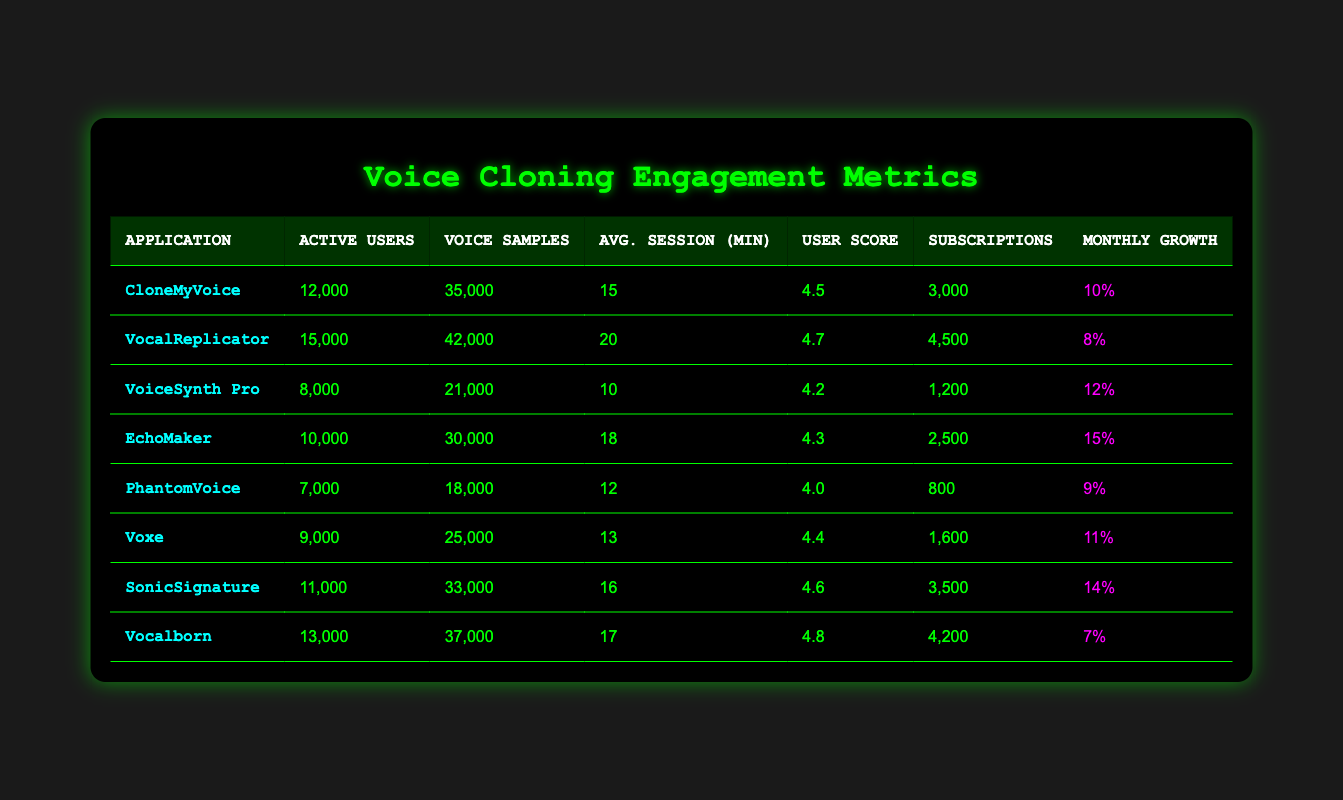What is the application with the highest user feedback score? By inspecting the user feedback scores in the table, Vocalborn has the highest score of 4.8.
Answer: Vocalborn How many voice samples did CloneMyVoice create? The table shows that CloneMyVoice created 35,000 voice samples.
Answer: 35,000 What is the average session duration for VocalReplicator? The average session duration for VocalReplicator, as seen in the table, is 20 minutes.
Answer: 20 minutes Which application has the fewest active users? PhantomVoice has the fewest active users at 7,000.
Answer: PhantomVoice How many total subscriptions do SonicSignature and Voxe have combined? SonicSignature has 3,500 subscriptions and Voxe has 1,600. Their total is 3,500 + 1,600 = 5,100.
Answer: 5,100 Is the monthly growth rate for EchoMaker higher than that of Vocalborn? EchoMaker has a monthly growth rate of 15%, while Vocalborn has a rate of 7%. So, yes, EchoMaker's growth rate is higher.
Answer: Yes What is the average user feedback score for all applications? The user feedback scores are 4.5, 4.7, 4.2, 4.3, 4.0, 4.4, 4.6, and 4.8. To find the average, we sum them up (4.5 + 4.7 + 4.2 + 4.3 + 4.0 + 4.4 + 4.6 + 4.8 = 36.5) and divide by 8, yielding an average of 4.56.
Answer: 4.56 What is the difference in active users between SonicSignature and VoiceSynth Pro? SonicSignature has 11,000 active users, while VoiceSynth Pro has 8,000. The difference is 11,000 - 8,000 = 3,000.
Answer: 3,000 Which application has the longest average session duration? VocalReplicator has the longest average session duration at 20 minutes.
Answer: VocalReplicator Do any applications have more than 10,000 active users and a user feedback score below 4.5? The applications with more than 10,000 active users, such as CloneMyVoice (4.5), VocalReplicator (4.7), EchoMaker (4.3), and SonicSignature (4.6), include EchoMaker which has a score below 4.5.
Answer: Yes What is the total number of voice samples created by all applications? Summing the voice samples: 35,000 + 42,000 + 21,000 + 30,000 + 18,000 + 25,000 + 33,000 + 37,000 = 231,000.
Answer: 231,000 